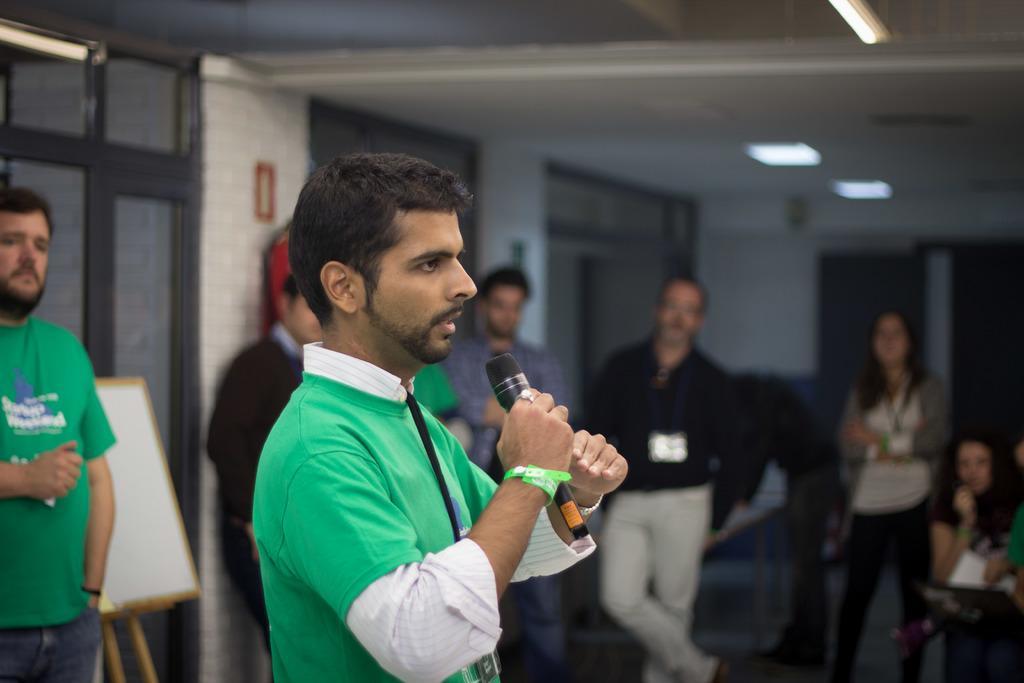In one or two sentences, can you explain what this image depicts? In this image we can see a man is standing by holding a mic in the hand. In the background there are few persons standing on the floor, lights on the ceiling, doors, a person is sitting and there are other objects. 